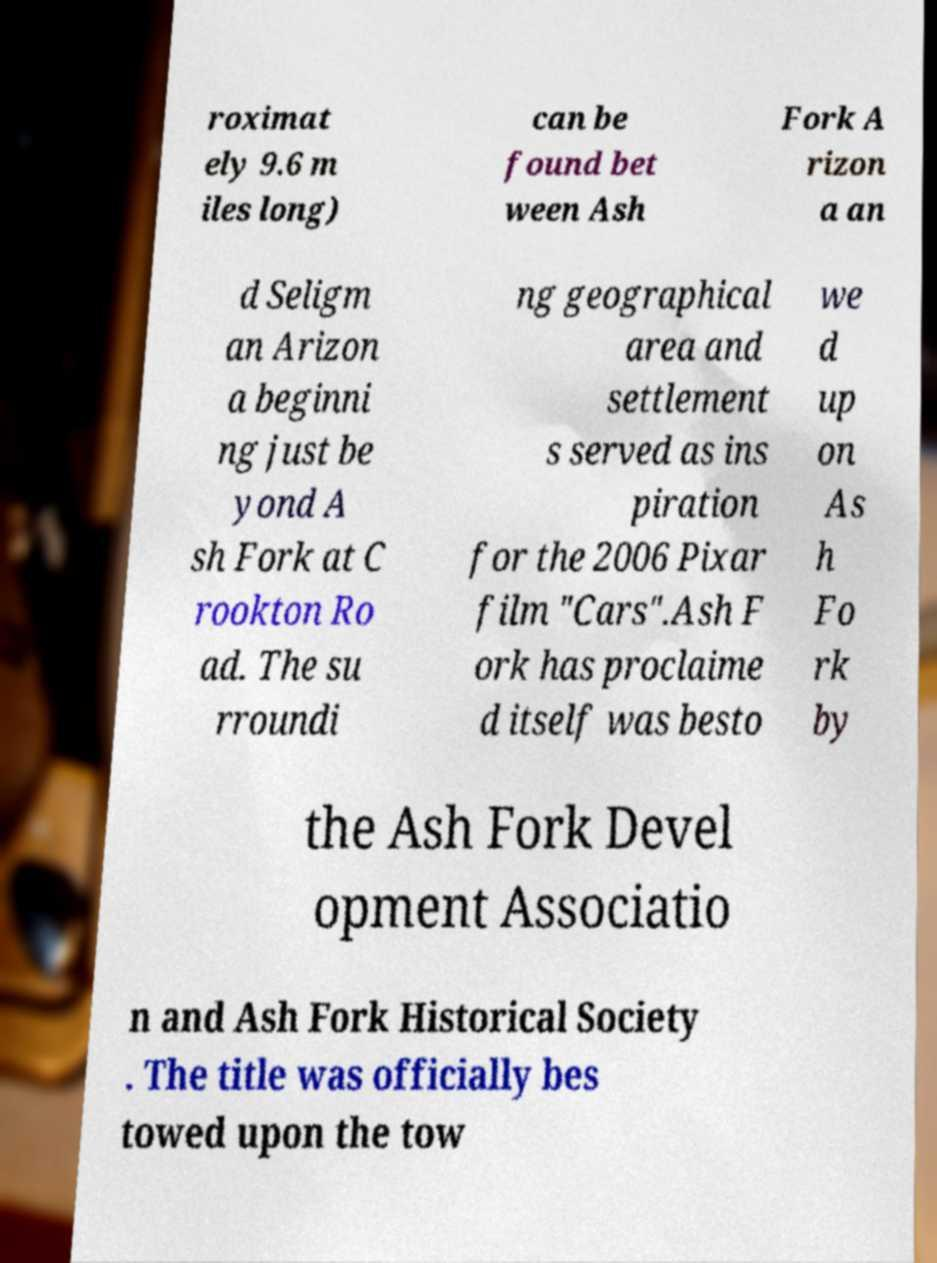Could you extract and type out the text from this image? roximat ely 9.6 m iles long) can be found bet ween Ash Fork A rizon a an d Seligm an Arizon a beginni ng just be yond A sh Fork at C rookton Ro ad. The su rroundi ng geographical area and settlement s served as ins piration for the 2006 Pixar film "Cars".Ash F ork has proclaime d itself was besto we d up on As h Fo rk by the Ash Fork Devel opment Associatio n and Ash Fork Historical Society . The title was officially bes towed upon the tow 